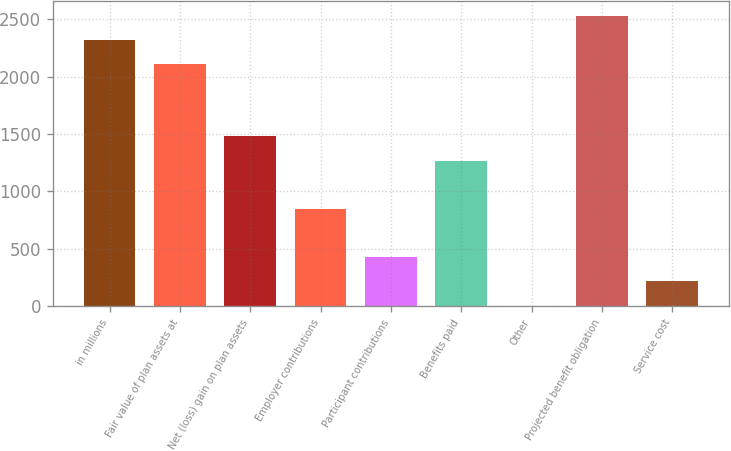Convert chart to OTSL. <chart><loc_0><loc_0><loc_500><loc_500><bar_chart><fcel>in millions<fcel>Fair value of plan assets at<fcel>Net (loss) gain on plan assets<fcel>Employer contributions<fcel>Participant contributions<fcel>Benefits paid<fcel>Other<fcel>Projected benefit obligation<fcel>Service cost<nl><fcel>2320.7<fcel>2110<fcel>1477.9<fcel>845.8<fcel>424.4<fcel>1267.2<fcel>3<fcel>2531.4<fcel>213.7<nl></chart> 